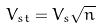Convert formula to latex. <formula><loc_0><loc_0><loc_500><loc_500>V _ { s t } = V _ { s } \sqrt { n }</formula> 